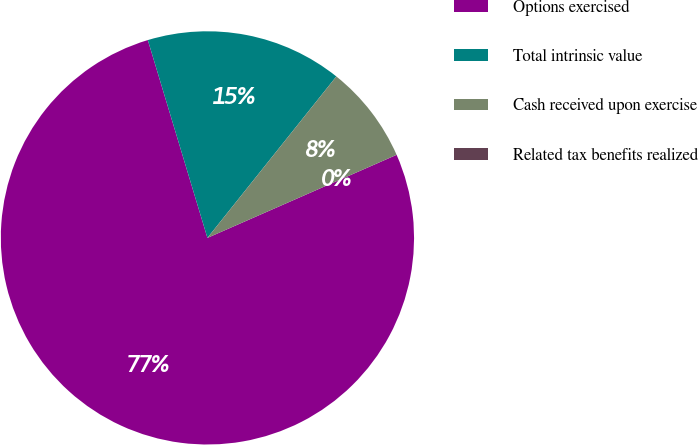<chart> <loc_0><loc_0><loc_500><loc_500><pie_chart><fcel>Options exercised<fcel>Total intrinsic value<fcel>Cash received upon exercise<fcel>Related tax benefits realized<nl><fcel>76.92%<fcel>15.38%<fcel>7.69%<fcel>0.0%<nl></chart> 